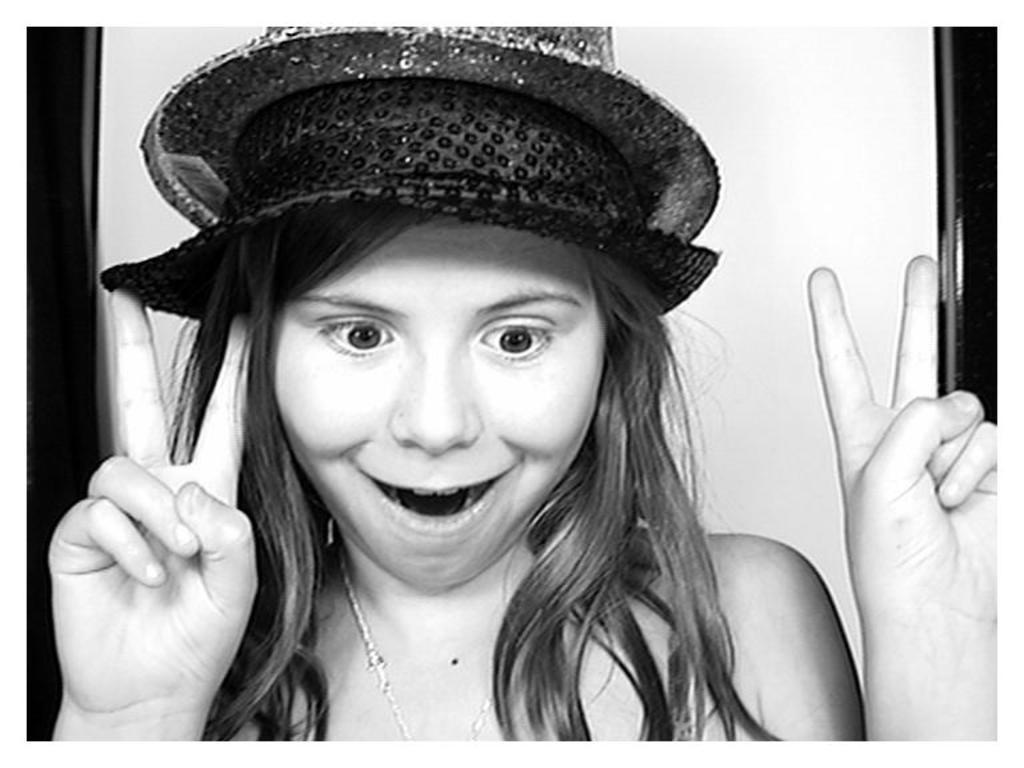What is the color scheme of the image? The image is black and white. Can you describe the main subject in the image? There is a person in the image. What is the person wearing on their head? The person is wearing a hat. What type of pear is sitting on the plate in the image? There is no pear or plate present in the image; it is a black and white image of a person wearing a hat. 